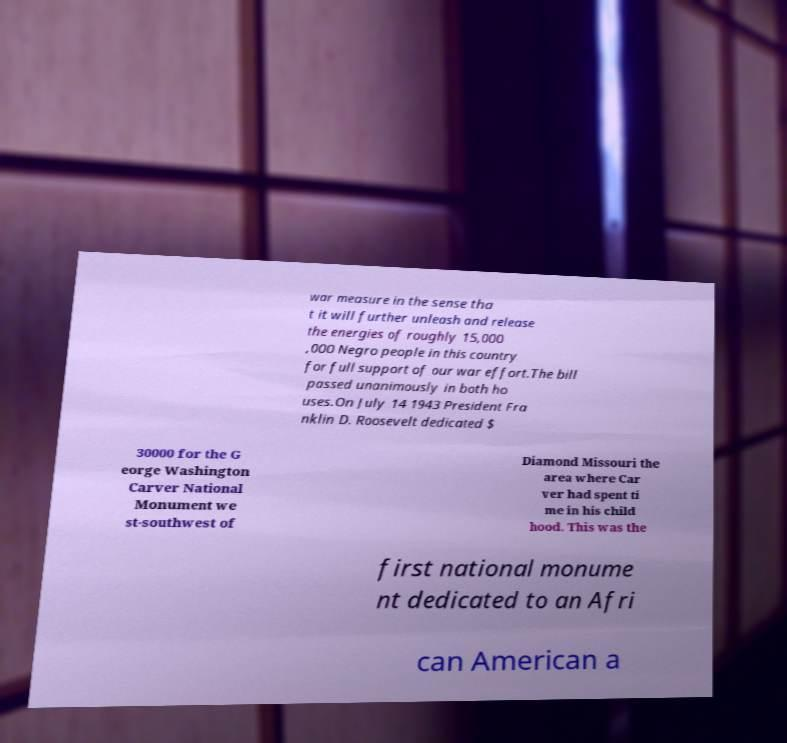Please identify and transcribe the text found in this image. war measure in the sense tha t it will further unleash and release the energies of roughly 15,000 ,000 Negro people in this country for full support of our war effort.The bill passed unanimously in both ho uses.On July 14 1943 President Fra nklin D. Roosevelt dedicated $ 30000 for the G eorge Washington Carver National Monument we st-southwest of Diamond Missouri the area where Car ver had spent ti me in his child hood. This was the first national monume nt dedicated to an Afri can American a 